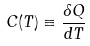Convert formula to latex. <formula><loc_0><loc_0><loc_500><loc_500>C ( T ) \equiv \frac { \delta Q } { d T }</formula> 